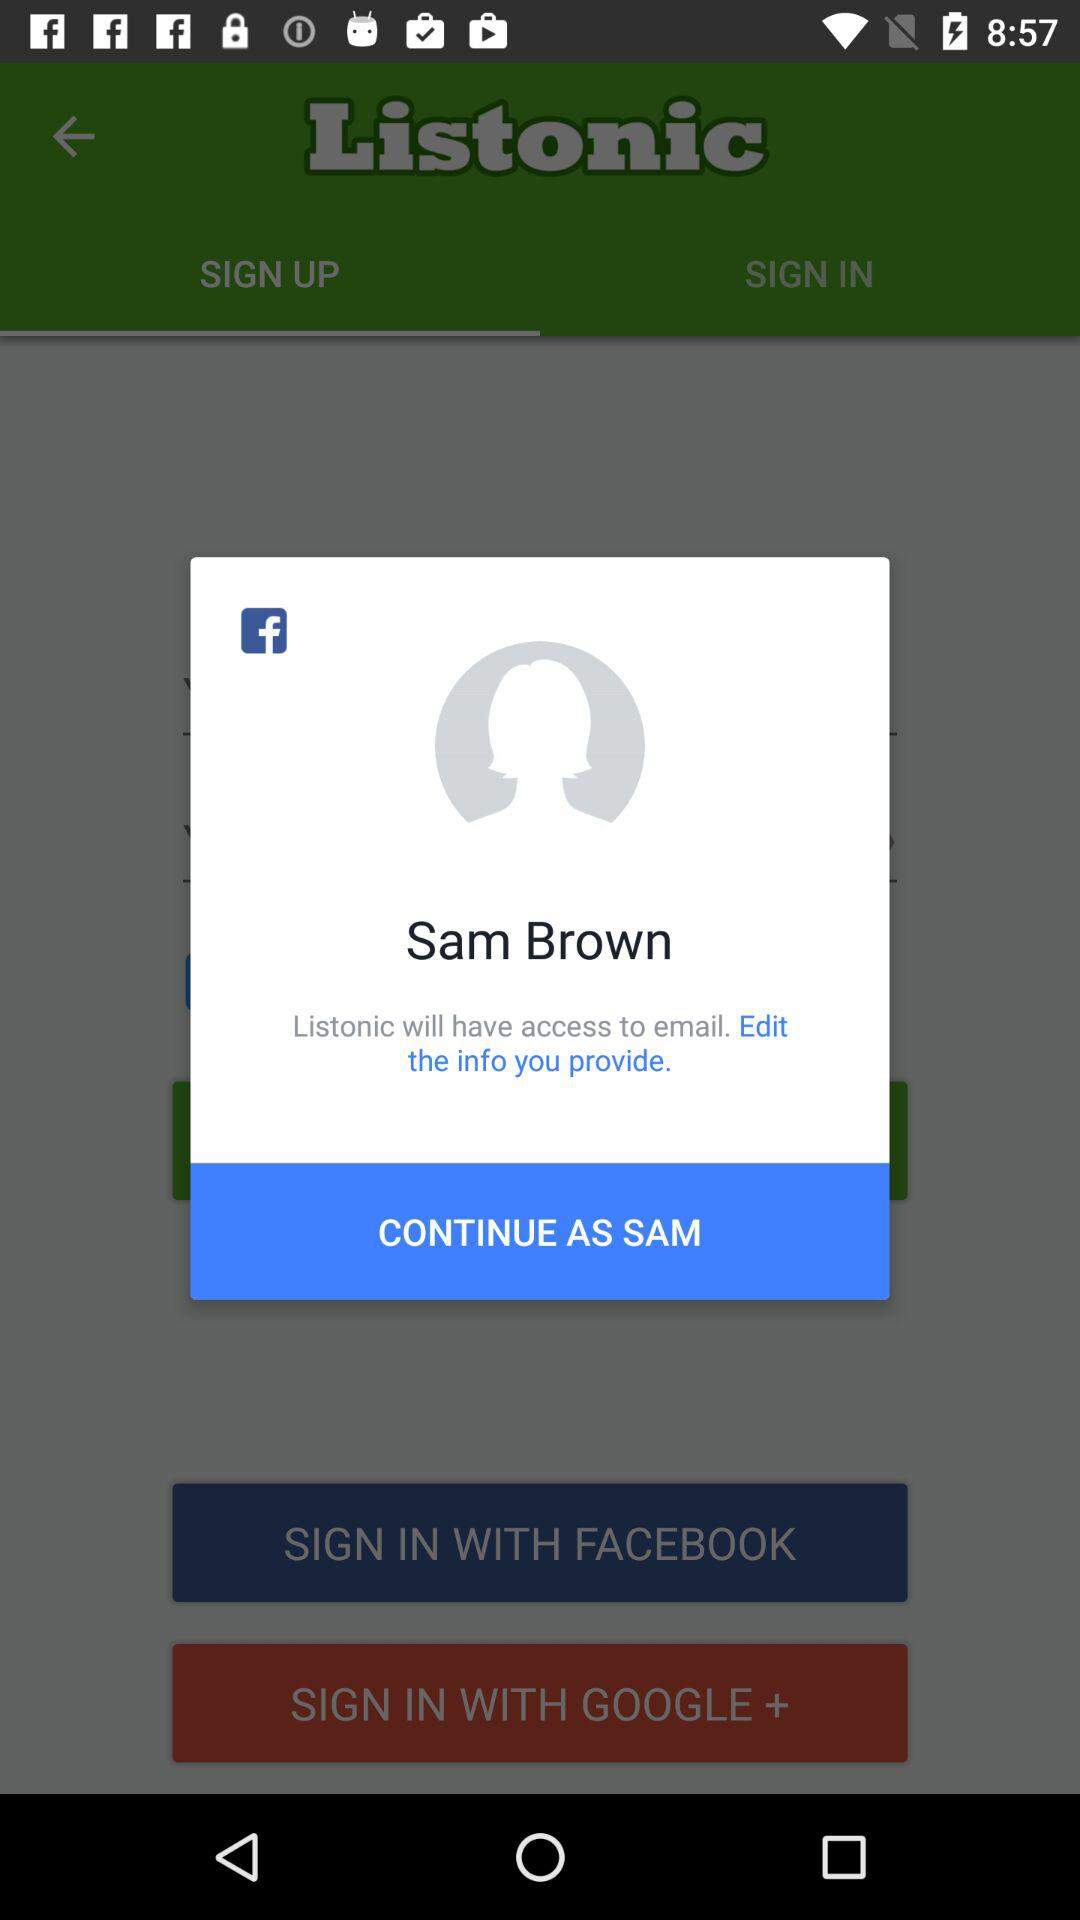Who developed the "Listonic" app?
When the provided information is insufficient, respond with <no answer>. <no answer> 